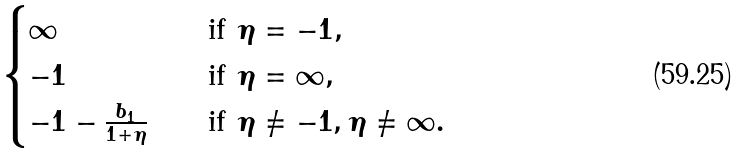Convert formula to latex. <formula><loc_0><loc_0><loc_500><loc_500>\begin{cases} \infty \quad & \text {if $\eta=-1$} , \\ - 1 \quad & \text {if $\eta=\infty$} , \\ - 1 - \frac { b _ { 1 } } { 1 + \eta } \quad & \text {if $\eta \not=-1, \eta \not=\infty$} . \end{cases}</formula> 